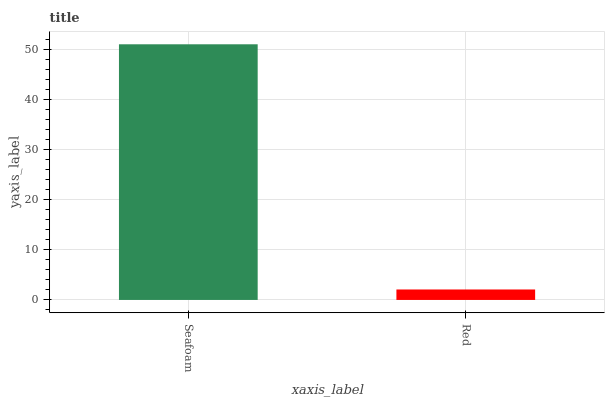Is Red the minimum?
Answer yes or no. Yes. Is Seafoam the maximum?
Answer yes or no. Yes. Is Red the maximum?
Answer yes or no. No. Is Seafoam greater than Red?
Answer yes or no. Yes. Is Red less than Seafoam?
Answer yes or no. Yes. Is Red greater than Seafoam?
Answer yes or no. No. Is Seafoam less than Red?
Answer yes or no. No. Is Seafoam the high median?
Answer yes or no. Yes. Is Red the low median?
Answer yes or no. Yes. Is Red the high median?
Answer yes or no. No. Is Seafoam the low median?
Answer yes or no. No. 